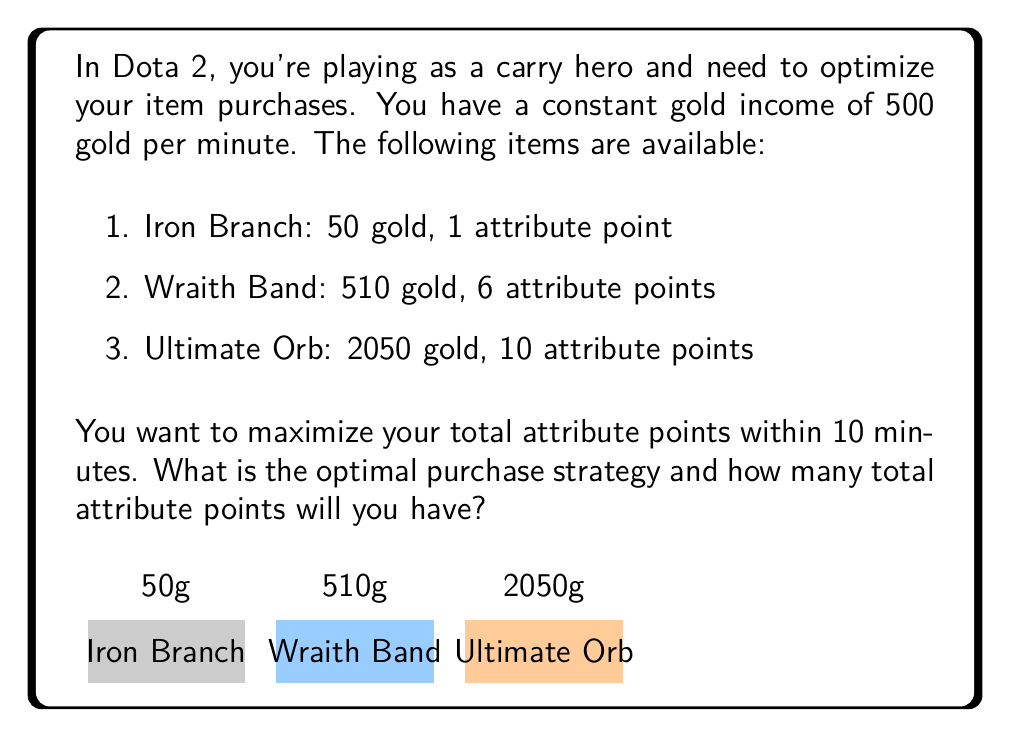Could you help me with this problem? Let's approach this step-by-step:

1) First, calculate the total gold available in 10 minutes:
   $$ \text{Total Gold} = 500 \text{ gold/min} \times 10 \text{ min} = 5000 \text{ gold} $$

2) Now, let's calculate the attribute points per gold for each item:
   - Iron Branch: $1/50 = 0.02$ points/gold
   - Wraith Band: $6/510 \approx 0.0118$ points/gold
   - Ultimate Orb: $10/2050 \approx 0.0049$ points/gold

3) The Iron Branch gives the most attribute points per gold, so we should buy as many as possible.

4) Calculate how many Iron Branches we can buy:
   $$ \text{Number of Iron Branches} = \left\lfloor\frac{5000}{50}\right\rfloor = 100 $$

5) Calculate the total attribute points from Iron Branches:
   $$ \text{Attribute Points} = 100 \times 1 = 100 $$

6) Calculate the remaining gold:
   $$ \text{Remaining Gold} = 5000 - (100 \times 50) = 0 $$

7) Since we have no gold left, we can't buy any more items.

Therefore, the optimal strategy is to buy 100 Iron Branches, which will give a total of 100 attribute points.
Answer: Buy 100 Iron Branches for 100 attribute points 